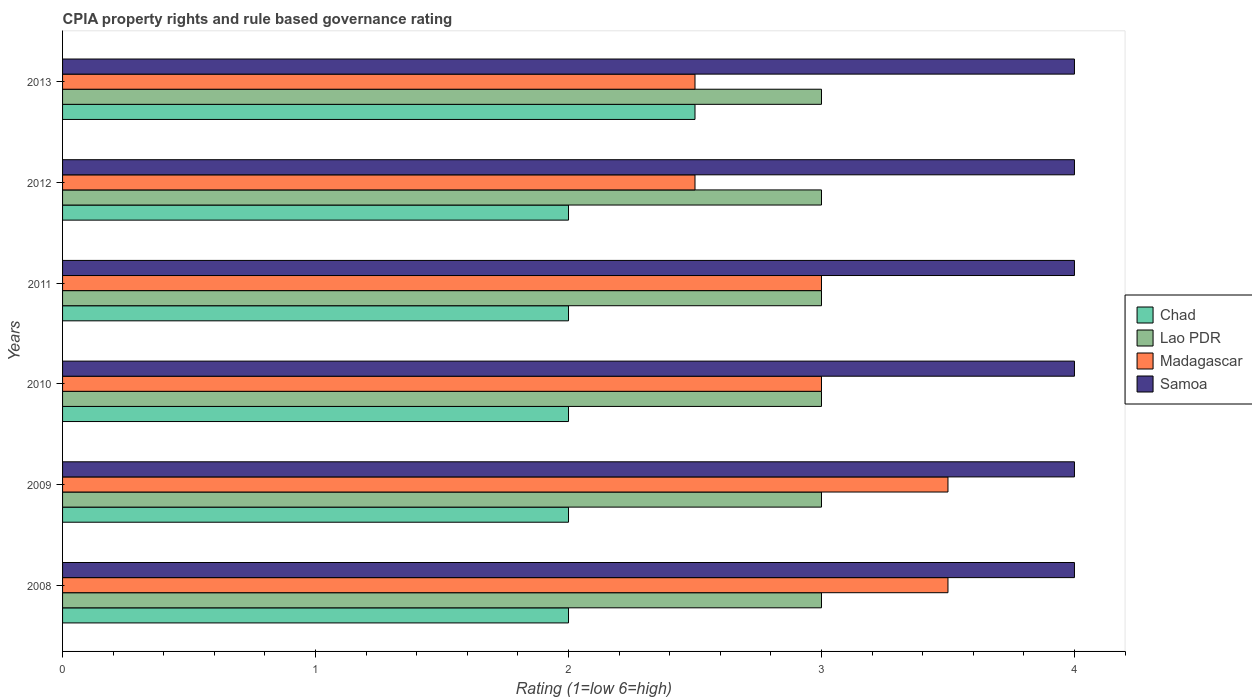How many different coloured bars are there?
Offer a very short reply. 4. Are the number of bars per tick equal to the number of legend labels?
Your response must be concise. Yes. Are the number of bars on each tick of the Y-axis equal?
Ensure brevity in your answer.  Yes. How many bars are there on the 4th tick from the top?
Ensure brevity in your answer.  4. How many bars are there on the 2nd tick from the bottom?
Provide a short and direct response. 4. In how many cases, is the number of bars for a given year not equal to the number of legend labels?
Your response must be concise. 0. What is the CPIA rating in Madagascar in 2008?
Ensure brevity in your answer.  3.5. Across all years, what is the maximum CPIA rating in Chad?
Ensure brevity in your answer.  2.5. Across all years, what is the minimum CPIA rating in Lao PDR?
Provide a short and direct response. 3. What is the total CPIA rating in Lao PDR in the graph?
Give a very brief answer. 18. In how many years, is the CPIA rating in Madagascar greater than 2.8 ?
Your answer should be compact. 4. What is the ratio of the CPIA rating in Chad in 2008 to that in 2009?
Offer a very short reply. 1. Is the difference between the CPIA rating in Lao PDR in 2010 and 2011 greater than the difference between the CPIA rating in Chad in 2010 and 2011?
Keep it short and to the point. No. What does the 1st bar from the top in 2013 represents?
Your answer should be compact. Samoa. What does the 3rd bar from the bottom in 2008 represents?
Provide a succinct answer. Madagascar. Is it the case that in every year, the sum of the CPIA rating in Madagascar and CPIA rating in Samoa is greater than the CPIA rating in Lao PDR?
Provide a succinct answer. Yes. Are all the bars in the graph horizontal?
Offer a terse response. Yes. How many years are there in the graph?
Your response must be concise. 6. Are the values on the major ticks of X-axis written in scientific E-notation?
Your answer should be very brief. No. Does the graph contain grids?
Your response must be concise. No. How many legend labels are there?
Your response must be concise. 4. What is the title of the graph?
Your answer should be compact. CPIA property rights and rule based governance rating. Does "Peru" appear as one of the legend labels in the graph?
Provide a succinct answer. No. What is the Rating (1=low 6=high) of Chad in 2008?
Your answer should be compact. 2. What is the Rating (1=low 6=high) of Samoa in 2008?
Your response must be concise. 4. What is the Rating (1=low 6=high) in Chad in 2009?
Your answer should be very brief. 2. What is the Rating (1=low 6=high) of Lao PDR in 2009?
Offer a terse response. 3. What is the Rating (1=low 6=high) in Samoa in 2009?
Make the answer very short. 4. What is the Rating (1=low 6=high) in Chad in 2010?
Your answer should be very brief. 2. What is the Rating (1=low 6=high) of Lao PDR in 2010?
Your answer should be compact. 3. What is the Rating (1=low 6=high) in Madagascar in 2010?
Offer a very short reply. 3. What is the Rating (1=low 6=high) of Chad in 2011?
Your answer should be very brief. 2. What is the Rating (1=low 6=high) of Madagascar in 2011?
Offer a terse response. 3. What is the Rating (1=low 6=high) of Chad in 2012?
Your answer should be compact. 2. What is the Rating (1=low 6=high) of Lao PDR in 2012?
Provide a succinct answer. 3. What is the Rating (1=low 6=high) of Samoa in 2012?
Offer a very short reply. 4. What is the Rating (1=low 6=high) in Chad in 2013?
Offer a terse response. 2.5. Across all years, what is the maximum Rating (1=low 6=high) of Lao PDR?
Give a very brief answer. 3. Across all years, what is the maximum Rating (1=low 6=high) of Madagascar?
Your response must be concise. 3.5. Across all years, what is the maximum Rating (1=low 6=high) of Samoa?
Ensure brevity in your answer.  4. Across all years, what is the minimum Rating (1=low 6=high) in Chad?
Make the answer very short. 2. Across all years, what is the minimum Rating (1=low 6=high) of Madagascar?
Offer a very short reply. 2.5. Across all years, what is the minimum Rating (1=low 6=high) of Samoa?
Your answer should be compact. 4. What is the total Rating (1=low 6=high) of Lao PDR in the graph?
Offer a terse response. 18. What is the total Rating (1=low 6=high) in Madagascar in the graph?
Provide a short and direct response. 18. What is the difference between the Rating (1=low 6=high) of Chad in 2008 and that in 2009?
Your response must be concise. 0. What is the difference between the Rating (1=low 6=high) of Samoa in 2008 and that in 2009?
Give a very brief answer. 0. What is the difference between the Rating (1=low 6=high) in Chad in 2008 and that in 2010?
Your answer should be very brief. 0. What is the difference between the Rating (1=low 6=high) in Madagascar in 2008 and that in 2010?
Provide a succinct answer. 0.5. What is the difference between the Rating (1=low 6=high) of Samoa in 2008 and that in 2010?
Provide a succinct answer. 0. What is the difference between the Rating (1=low 6=high) in Chad in 2008 and that in 2011?
Offer a terse response. 0. What is the difference between the Rating (1=low 6=high) of Madagascar in 2008 and that in 2011?
Provide a succinct answer. 0.5. What is the difference between the Rating (1=low 6=high) of Samoa in 2008 and that in 2011?
Keep it short and to the point. 0. What is the difference between the Rating (1=low 6=high) in Chad in 2008 and that in 2012?
Make the answer very short. 0. What is the difference between the Rating (1=low 6=high) in Lao PDR in 2008 and that in 2013?
Your answer should be compact. 0. What is the difference between the Rating (1=low 6=high) of Chad in 2009 and that in 2010?
Your response must be concise. 0. What is the difference between the Rating (1=low 6=high) of Lao PDR in 2009 and that in 2010?
Your answer should be very brief. 0. What is the difference between the Rating (1=low 6=high) in Samoa in 2009 and that in 2010?
Your response must be concise. 0. What is the difference between the Rating (1=low 6=high) of Chad in 2009 and that in 2011?
Make the answer very short. 0. What is the difference between the Rating (1=low 6=high) of Samoa in 2009 and that in 2011?
Give a very brief answer. 0. What is the difference between the Rating (1=low 6=high) of Madagascar in 2009 and that in 2012?
Your answer should be very brief. 1. What is the difference between the Rating (1=low 6=high) in Samoa in 2009 and that in 2012?
Make the answer very short. 0. What is the difference between the Rating (1=low 6=high) in Lao PDR in 2009 and that in 2013?
Keep it short and to the point. 0. What is the difference between the Rating (1=low 6=high) of Madagascar in 2009 and that in 2013?
Give a very brief answer. 1. What is the difference between the Rating (1=low 6=high) of Samoa in 2009 and that in 2013?
Make the answer very short. 0. What is the difference between the Rating (1=low 6=high) of Chad in 2010 and that in 2011?
Keep it short and to the point. 0. What is the difference between the Rating (1=low 6=high) in Lao PDR in 2010 and that in 2011?
Keep it short and to the point. 0. What is the difference between the Rating (1=low 6=high) of Lao PDR in 2010 and that in 2012?
Provide a succinct answer. 0. What is the difference between the Rating (1=low 6=high) of Chad in 2010 and that in 2013?
Ensure brevity in your answer.  -0.5. What is the difference between the Rating (1=low 6=high) in Madagascar in 2010 and that in 2013?
Your response must be concise. 0.5. What is the difference between the Rating (1=low 6=high) in Lao PDR in 2011 and that in 2012?
Provide a succinct answer. 0. What is the difference between the Rating (1=low 6=high) in Chad in 2011 and that in 2013?
Your answer should be compact. -0.5. What is the difference between the Rating (1=low 6=high) of Lao PDR in 2011 and that in 2013?
Give a very brief answer. 0. What is the difference between the Rating (1=low 6=high) in Madagascar in 2011 and that in 2013?
Provide a succinct answer. 0.5. What is the difference between the Rating (1=low 6=high) in Chad in 2012 and that in 2013?
Give a very brief answer. -0.5. What is the difference between the Rating (1=low 6=high) in Chad in 2008 and the Rating (1=low 6=high) in Samoa in 2009?
Give a very brief answer. -2. What is the difference between the Rating (1=low 6=high) of Madagascar in 2008 and the Rating (1=low 6=high) of Samoa in 2009?
Make the answer very short. -0.5. What is the difference between the Rating (1=low 6=high) in Chad in 2008 and the Rating (1=low 6=high) in Lao PDR in 2010?
Your answer should be very brief. -1. What is the difference between the Rating (1=low 6=high) of Chad in 2008 and the Rating (1=low 6=high) of Madagascar in 2010?
Give a very brief answer. -1. What is the difference between the Rating (1=low 6=high) in Lao PDR in 2008 and the Rating (1=low 6=high) in Madagascar in 2010?
Provide a succinct answer. 0. What is the difference between the Rating (1=low 6=high) of Lao PDR in 2008 and the Rating (1=low 6=high) of Samoa in 2010?
Your answer should be compact. -1. What is the difference between the Rating (1=low 6=high) of Madagascar in 2008 and the Rating (1=low 6=high) of Samoa in 2010?
Your answer should be compact. -0.5. What is the difference between the Rating (1=low 6=high) of Chad in 2008 and the Rating (1=low 6=high) of Lao PDR in 2011?
Offer a terse response. -1. What is the difference between the Rating (1=low 6=high) of Chad in 2008 and the Rating (1=low 6=high) of Madagascar in 2011?
Provide a short and direct response. -1. What is the difference between the Rating (1=low 6=high) in Chad in 2008 and the Rating (1=low 6=high) in Samoa in 2011?
Offer a very short reply. -2. What is the difference between the Rating (1=low 6=high) of Chad in 2008 and the Rating (1=low 6=high) of Lao PDR in 2012?
Ensure brevity in your answer.  -1. What is the difference between the Rating (1=low 6=high) in Chad in 2008 and the Rating (1=low 6=high) in Madagascar in 2012?
Offer a very short reply. -0.5. What is the difference between the Rating (1=low 6=high) in Lao PDR in 2008 and the Rating (1=low 6=high) in Madagascar in 2012?
Make the answer very short. 0.5. What is the difference between the Rating (1=low 6=high) in Lao PDR in 2008 and the Rating (1=low 6=high) in Samoa in 2012?
Your response must be concise. -1. What is the difference between the Rating (1=low 6=high) in Madagascar in 2008 and the Rating (1=low 6=high) in Samoa in 2012?
Provide a succinct answer. -0.5. What is the difference between the Rating (1=low 6=high) of Chad in 2008 and the Rating (1=low 6=high) of Samoa in 2013?
Make the answer very short. -2. What is the difference between the Rating (1=low 6=high) of Lao PDR in 2008 and the Rating (1=low 6=high) of Madagascar in 2013?
Provide a succinct answer. 0.5. What is the difference between the Rating (1=low 6=high) of Lao PDR in 2008 and the Rating (1=low 6=high) of Samoa in 2013?
Make the answer very short. -1. What is the difference between the Rating (1=low 6=high) in Madagascar in 2008 and the Rating (1=low 6=high) in Samoa in 2013?
Give a very brief answer. -0.5. What is the difference between the Rating (1=low 6=high) in Chad in 2009 and the Rating (1=low 6=high) in Lao PDR in 2010?
Provide a succinct answer. -1. What is the difference between the Rating (1=low 6=high) of Chad in 2009 and the Rating (1=low 6=high) of Madagascar in 2010?
Give a very brief answer. -1. What is the difference between the Rating (1=low 6=high) in Chad in 2009 and the Rating (1=low 6=high) in Samoa in 2010?
Your answer should be compact. -2. What is the difference between the Rating (1=low 6=high) of Lao PDR in 2009 and the Rating (1=low 6=high) of Madagascar in 2010?
Your answer should be compact. 0. What is the difference between the Rating (1=low 6=high) in Madagascar in 2009 and the Rating (1=low 6=high) in Samoa in 2010?
Keep it short and to the point. -0.5. What is the difference between the Rating (1=low 6=high) of Chad in 2009 and the Rating (1=low 6=high) of Lao PDR in 2011?
Keep it short and to the point. -1. What is the difference between the Rating (1=low 6=high) in Chad in 2009 and the Rating (1=low 6=high) in Madagascar in 2011?
Your answer should be very brief. -1. What is the difference between the Rating (1=low 6=high) in Chad in 2009 and the Rating (1=low 6=high) in Lao PDR in 2012?
Your answer should be compact. -1. What is the difference between the Rating (1=low 6=high) of Chad in 2009 and the Rating (1=low 6=high) of Samoa in 2012?
Ensure brevity in your answer.  -2. What is the difference between the Rating (1=low 6=high) in Chad in 2009 and the Rating (1=low 6=high) in Samoa in 2013?
Your answer should be very brief. -2. What is the difference between the Rating (1=low 6=high) in Lao PDR in 2009 and the Rating (1=low 6=high) in Samoa in 2013?
Your response must be concise. -1. What is the difference between the Rating (1=low 6=high) in Chad in 2010 and the Rating (1=low 6=high) in Lao PDR in 2011?
Provide a short and direct response. -1. What is the difference between the Rating (1=low 6=high) of Lao PDR in 2010 and the Rating (1=low 6=high) of Samoa in 2011?
Your answer should be compact. -1. What is the difference between the Rating (1=low 6=high) of Madagascar in 2010 and the Rating (1=low 6=high) of Samoa in 2011?
Give a very brief answer. -1. What is the difference between the Rating (1=low 6=high) in Chad in 2010 and the Rating (1=low 6=high) in Samoa in 2012?
Offer a very short reply. -2. What is the difference between the Rating (1=low 6=high) of Madagascar in 2010 and the Rating (1=low 6=high) of Samoa in 2012?
Make the answer very short. -1. What is the difference between the Rating (1=low 6=high) of Chad in 2010 and the Rating (1=low 6=high) of Lao PDR in 2013?
Your response must be concise. -1. What is the difference between the Rating (1=low 6=high) in Chad in 2010 and the Rating (1=low 6=high) in Samoa in 2013?
Offer a terse response. -2. What is the difference between the Rating (1=low 6=high) of Lao PDR in 2010 and the Rating (1=low 6=high) of Madagascar in 2013?
Your answer should be compact. 0.5. What is the difference between the Rating (1=low 6=high) of Chad in 2011 and the Rating (1=low 6=high) of Samoa in 2012?
Your response must be concise. -2. What is the difference between the Rating (1=low 6=high) of Madagascar in 2011 and the Rating (1=low 6=high) of Samoa in 2012?
Your answer should be compact. -1. What is the difference between the Rating (1=low 6=high) in Chad in 2011 and the Rating (1=low 6=high) in Lao PDR in 2013?
Provide a short and direct response. -1. What is the difference between the Rating (1=low 6=high) in Chad in 2011 and the Rating (1=low 6=high) in Madagascar in 2013?
Offer a terse response. -0.5. What is the difference between the Rating (1=low 6=high) of Lao PDR in 2011 and the Rating (1=low 6=high) of Madagascar in 2013?
Keep it short and to the point. 0.5. What is the difference between the Rating (1=low 6=high) in Madagascar in 2011 and the Rating (1=low 6=high) in Samoa in 2013?
Keep it short and to the point. -1. What is the difference between the Rating (1=low 6=high) in Chad in 2012 and the Rating (1=low 6=high) in Lao PDR in 2013?
Make the answer very short. -1. What is the difference between the Rating (1=low 6=high) in Lao PDR in 2012 and the Rating (1=low 6=high) in Madagascar in 2013?
Ensure brevity in your answer.  0.5. What is the difference between the Rating (1=low 6=high) of Madagascar in 2012 and the Rating (1=low 6=high) of Samoa in 2013?
Your answer should be very brief. -1.5. What is the average Rating (1=low 6=high) of Chad per year?
Keep it short and to the point. 2.08. What is the average Rating (1=low 6=high) of Lao PDR per year?
Make the answer very short. 3. What is the average Rating (1=low 6=high) in Madagascar per year?
Offer a very short reply. 3. In the year 2008, what is the difference between the Rating (1=low 6=high) of Madagascar and Rating (1=low 6=high) of Samoa?
Provide a succinct answer. -0.5. In the year 2009, what is the difference between the Rating (1=low 6=high) in Lao PDR and Rating (1=low 6=high) in Madagascar?
Your answer should be compact. -0.5. In the year 2009, what is the difference between the Rating (1=low 6=high) in Lao PDR and Rating (1=low 6=high) in Samoa?
Provide a succinct answer. -1. In the year 2009, what is the difference between the Rating (1=low 6=high) in Madagascar and Rating (1=low 6=high) in Samoa?
Make the answer very short. -0.5. In the year 2010, what is the difference between the Rating (1=low 6=high) in Chad and Rating (1=low 6=high) in Lao PDR?
Keep it short and to the point. -1. In the year 2010, what is the difference between the Rating (1=low 6=high) in Chad and Rating (1=low 6=high) in Samoa?
Your answer should be very brief. -2. In the year 2010, what is the difference between the Rating (1=low 6=high) of Madagascar and Rating (1=low 6=high) of Samoa?
Offer a terse response. -1. In the year 2011, what is the difference between the Rating (1=low 6=high) of Chad and Rating (1=low 6=high) of Lao PDR?
Keep it short and to the point. -1. In the year 2011, what is the difference between the Rating (1=low 6=high) of Lao PDR and Rating (1=low 6=high) of Samoa?
Give a very brief answer. -1. In the year 2012, what is the difference between the Rating (1=low 6=high) of Chad and Rating (1=low 6=high) of Lao PDR?
Offer a terse response. -1. In the year 2012, what is the difference between the Rating (1=low 6=high) of Chad and Rating (1=low 6=high) of Samoa?
Ensure brevity in your answer.  -2. In the year 2012, what is the difference between the Rating (1=low 6=high) of Lao PDR and Rating (1=low 6=high) of Madagascar?
Offer a terse response. 0.5. In the year 2012, what is the difference between the Rating (1=low 6=high) of Lao PDR and Rating (1=low 6=high) of Samoa?
Give a very brief answer. -1. What is the ratio of the Rating (1=low 6=high) in Lao PDR in 2008 to that in 2009?
Ensure brevity in your answer.  1. What is the ratio of the Rating (1=low 6=high) of Chad in 2008 to that in 2010?
Your response must be concise. 1. What is the ratio of the Rating (1=low 6=high) in Samoa in 2008 to that in 2010?
Offer a very short reply. 1. What is the ratio of the Rating (1=low 6=high) of Chad in 2008 to that in 2011?
Offer a terse response. 1. What is the ratio of the Rating (1=low 6=high) in Madagascar in 2008 to that in 2011?
Provide a succinct answer. 1.17. What is the ratio of the Rating (1=low 6=high) of Samoa in 2008 to that in 2011?
Your answer should be compact. 1. What is the ratio of the Rating (1=low 6=high) of Lao PDR in 2008 to that in 2012?
Keep it short and to the point. 1. What is the ratio of the Rating (1=low 6=high) in Chad in 2008 to that in 2013?
Provide a short and direct response. 0.8. What is the ratio of the Rating (1=low 6=high) of Lao PDR in 2008 to that in 2013?
Keep it short and to the point. 1. What is the ratio of the Rating (1=low 6=high) of Madagascar in 2008 to that in 2013?
Your answer should be compact. 1.4. What is the ratio of the Rating (1=low 6=high) of Samoa in 2008 to that in 2013?
Your answer should be compact. 1. What is the ratio of the Rating (1=low 6=high) in Lao PDR in 2009 to that in 2010?
Your response must be concise. 1. What is the ratio of the Rating (1=low 6=high) of Samoa in 2009 to that in 2010?
Ensure brevity in your answer.  1. What is the ratio of the Rating (1=low 6=high) in Chad in 2009 to that in 2011?
Offer a terse response. 1. What is the ratio of the Rating (1=low 6=high) in Samoa in 2009 to that in 2011?
Ensure brevity in your answer.  1. What is the ratio of the Rating (1=low 6=high) of Madagascar in 2009 to that in 2012?
Offer a terse response. 1.4. What is the ratio of the Rating (1=low 6=high) of Chad in 2009 to that in 2013?
Provide a short and direct response. 0.8. What is the ratio of the Rating (1=low 6=high) in Samoa in 2009 to that in 2013?
Offer a very short reply. 1. What is the ratio of the Rating (1=low 6=high) in Chad in 2010 to that in 2011?
Offer a terse response. 1. What is the ratio of the Rating (1=low 6=high) in Lao PDR in 2010 to that in 2011?
Provide a short and direct response. 1. What is the ratio of the Rating (1=low 6=high) in Madagascar in 2010 to that in 2011?
Make the answer very short. 1. What is the ratio of the Rating (1=low 6=high) of Chad in 2010 to that in 2012?
Provide a succinct answer. 1. What is the ratio of the Rating (1=low 6=high) in Madagascar in 2010 to that in 2012?
Make the answer very short. 1.2. What is the ratio of the Rating (1=low 6=high) in Chad in 2010 to that in 2013?
Keep it short and to the point. 0.8. What is the ratio of the Rating (1=low 6=high) in Lao PDR in 2010 to that in 2013?
Keep it short and to the point. 1. What is the ratio of the Rating (1=low 6=high) in Chad in 2011 to that in 2012?
Your answer should be compact. 1. What is the ratio of the Rating (1=low 6=high) in Lao PDR in 2011 to that in 2012?
Your answer should be very brief. 1. What is the ratio of the Rating (1=low 6=high) of Madagascar in 2011 to that in 2012?
Offer a very short reply. 1.2. What is the ratio of the Rating (1=low 6=high) of Samoa in 2011 to that in 2013?
Your answer should be compact. 1. What is the ratio of the Rating (1=low 6=high) in Chad in 2012 to that in 2013?
Offer a terse response. 0.8. What is the ratio of the Rating (1=low 6=high) of Madagascar in 2012 to that in 2013?
Provide a short and direct response. 1. What is the difference between the highest and the second highest Rating (1=low 6=high) in Samoa?
Make the answer very short. 0. What is the difference between the highest and the lowest Rating (1=low 6=high) of Lao PDR?
Your answer should be compact. 0. What is the difference between the highest and the lowest Rating (1=low 6=high) of Madagascar?
Your answer should be very brief. 1. 